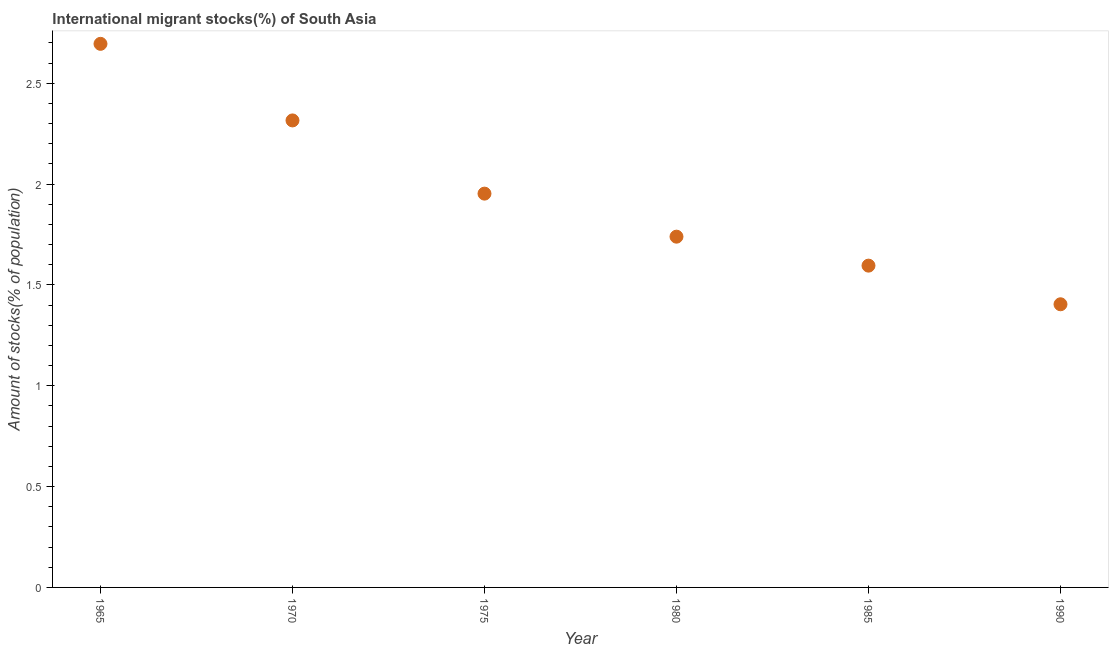What is the number of international migrant stocks in 1975?
Offer a very short reply. 1.95. Across all years, what is the maximum number of international migrant stocks?
Your answer should be very brief. 2.7. Across all years, what is the minimum number of international migrant stocks?
Your answer should be very brief. 1.4. In which year was the number of international migrant stocks maximum?
Provide a short and direct response. 1965. In which year was the number of international migrant stocks minimum?
Offer a terse response. 1990. What is the sum of the number of international migrant stocks?
Keep it short and to the point. 11.7. What is the difference between the number of international migrant stocks in 1975 and 1980?
Keep it short and to the point. 0.21. What is the average number of international migrant stocks per year?
Provide a succinct answer. 1.95. What is the median number of international migrant stocks?
Your answer should be very brief. 1.85. What is the ratio of the number of international migrant stocks in 1965 to that in 1970?
Make the answer very short. 1.16. Is the number of international migrant stocks in 1980 less than that in 1990?
Give a very brief answer. No. Is the difference between the number of international migrant stocks in 1965 and 1980 greater than the difference between any two years?
Offer a terse response. No. What is the difference between the highest and the second highest number of international migrant stocks?
Keep it short and to the point. 0.38. Is the sum of the number of international migrant stocks in 1985 and 1990 greater than the maximum number of international migrant stocks across all years?
Ensure brevity in your answer.  Yes. What is the difference between the highest and the lowest number of international migrant stocks?
Provide a succinct answer. 1.29. What is the difference between two consecutive major ticks on the Y-axis?
Keep it short and to the point. 0.5. Does the graph contain any zero values?
Your answer should be compact. No. Does the graph contain grids?
Offer a very short reply. No. What is the title of the graph?
Your answer should be compact. International migrant stocks(%) of South Asia. What is the label or title of the Y-axis?
Provide a succinct answer. Amount of stocks(% of population). What is the Amount of stocks(% of population) in 1965?
Your answer should be compact. 2.7. What is the Amount of stocks(% of population) in 1970?
Offer a terse response. 2.32. What is the Amount of stocks(% of population) in 1975?
Give a very brief answer. 1.95. What is the Amount of stocks(% of population) in 1980?
Offer a terse response. 1.74. What is the Amount of stocks(% of population) in 1985?
Ensure brevity in your answer.  1.6. What is the Amount of stocks(% of population) in 1990?
Keep it short and to the point. 1.4. What is the difference between the Amount of stocks(% of population) in 1965 and 1970?
Keep it short and to the point. 0.38. What is the difference between the Amount of stocks(% of population) in 1965 and 1975?
Provide a succinct answer. 0.74. What is the difference between the Amount of stocks(% of population) in 1965 and 1980?
Make the answer very short. 0.96. What is the difference between the Amount of stocks(% of population) in 1965 and 1985?
Offer a terse response. 1.1. What is the difference between the Amount of stocks(% of population) in 1965 and 1990?
Keep it short and to the point. 1.29. What is the difference between the Amount of stocks(% of population) in 1970 and 1975?
Offer a very short reply. 0.36. What is the difference between the Amount of stocks(% of population) in 1970 and 1980?
Provide a succinct answer. 0.58. What is the difference between the Amount of stocks(% of population) in 1970 and 1985?
Offer a terse response. 0.72. What is the difference between the Amount of stocks(% of population) in 1970 and 1990?
Provide a short and direct response. 0.91. What is the difference between the Amount of stocks(% of population) in 1975 and 1980?
Provide a succinct answer. 0.21. What is the difference between the Amount of stocks(% of population) in 1975 and 1985?
Provide a short and direct response. 0.36. What is the difference between the Amount of stocks(% of population) in 1975 and 1990?
Offer a terse response. 0.55. What is the difference between the Amount of stocks(% of population) in 1980 and 1985?
Keep it short and to the point. 0.14. What is the difference between the Amount of stocks(% of population) in 1980 and 1990?
Ensure brevity in your answer.  0.34. What is the difference between the Amount of stocks(% of population) in 1985 and 1990?
Provide a succinct answer. 0.19. What is the ratio of the Amount of stocks(% of population) in 1965 to that in 1970?
Make the answer very short. 1.16. What is the ratio of the Amount of stocks(% of population) in 1965 to that in 1975?
Offer a very short reply. 1.38. What is the ratio of the Amount of stocks(% of population) in 1965 to that in 1980?
Give a very brief answer. 1.55. What is the ratio of the Amount of stocks(% of population) in 1965 to that in 1985?
Offer a very short reply. 1.69. What is the ratio of the Amount of stocks(% of population) in 1965 to that in 1990?
Your answer should be very brief. 1.92. What is the ratio of the Amount of stocks(% of population) in 1970 to that in 1975?
Offer a very short reply. 1.19. What is the ratio of the Amount of stocks(% of population) in 1970 to that in 1980?
Offer a terse response. 1.33. What is the ratio of the Amount of stocks(% of population) in 1970 to that in 1985?
Ensure brevity in your answer.  1.45. What is the ratio of the Amount of stocks(% of population) in 1970 to that in 1990?
Offer a terse response. 1.65. What is the ratio of the Amount of stocks(% of population) in 1975 to that in 1980?
Keep it short and to the point. 1.12. What is the ratio of the Amount of stocks(% of population) in 1975 to that in 1985?
Provide a short and direct response. 1.22. What is the ratio of the Amount of stocks(% of population) in 1975 to that in 1990?
Your answer should be compact. 1.39. What is the ratio of the Amount of stocks(% of population) in 1980 to that in 1985?
Offer a terse response. 1.09. What is the ratio of the Amount of stocks(% of population) in 1980 to that in 1990?
Make the answer very short. 1.24. What is the ratio of the Amount of stocks(% of population) in 1985 to that in 1990?
Offer a terse response. 1.14. 